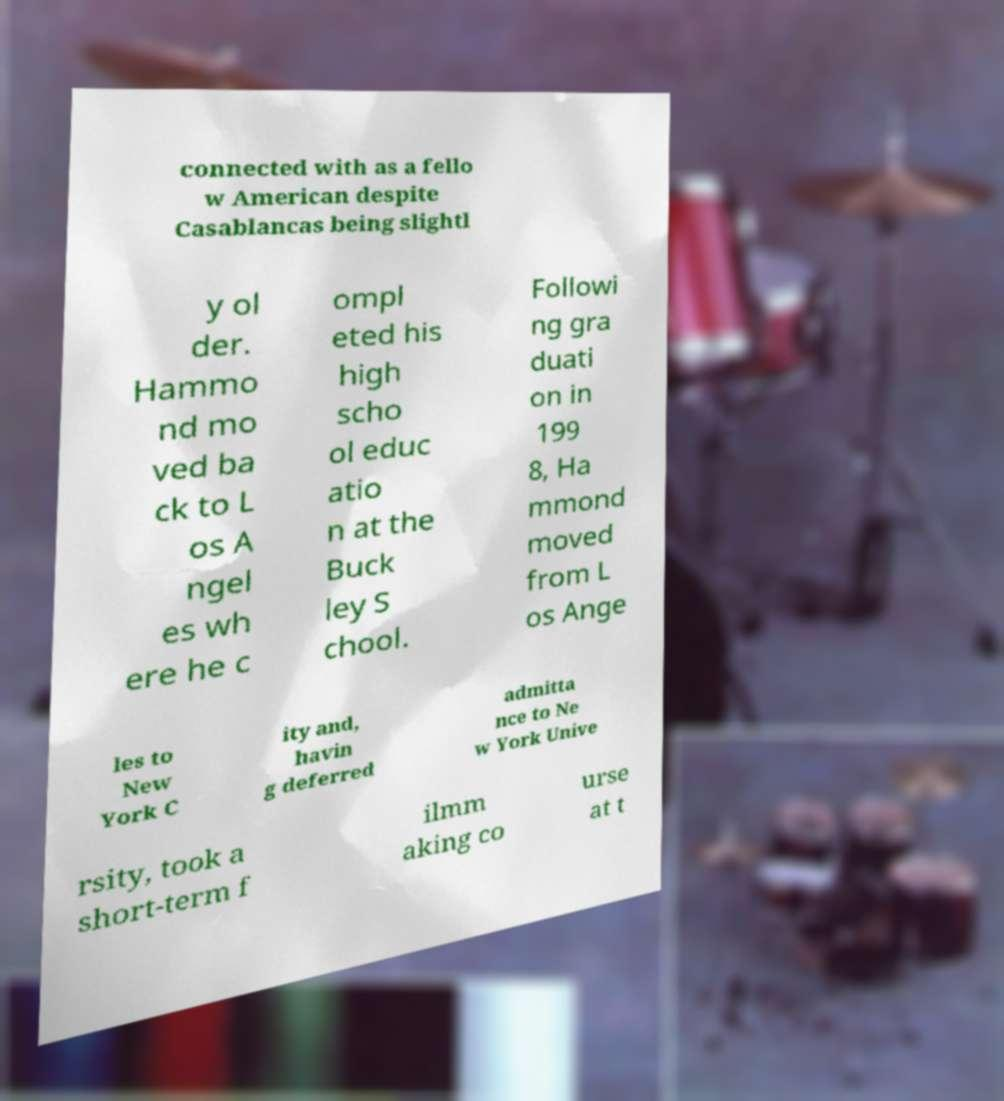There's text embedded in this image that I need extracted. Can you transcribe it verbatim? connected with as a fello w American despite Casablancas being slightl y ol der. Hammo nd mo ved ba ck to L os A ngel es wh ere he c ompl eted his high scho ol educ atio n at the Buck ley S chool. Followi ng gra duati on in 199 8, Ha mmond moved from L os Ange les to New York C ity and, havin g deferred admitta nce to Ne w York Unive rsity, took a short-term f ilmm aking co urse at t 